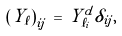<formula> <loc_0><loc_0><loc_500><loc_500>\left ( Y _ { \ell } \right ) _ { i j } \, = \, Y _ { \ell _ { i } } ^ { d } \delta _ { i j } ,</formula> 